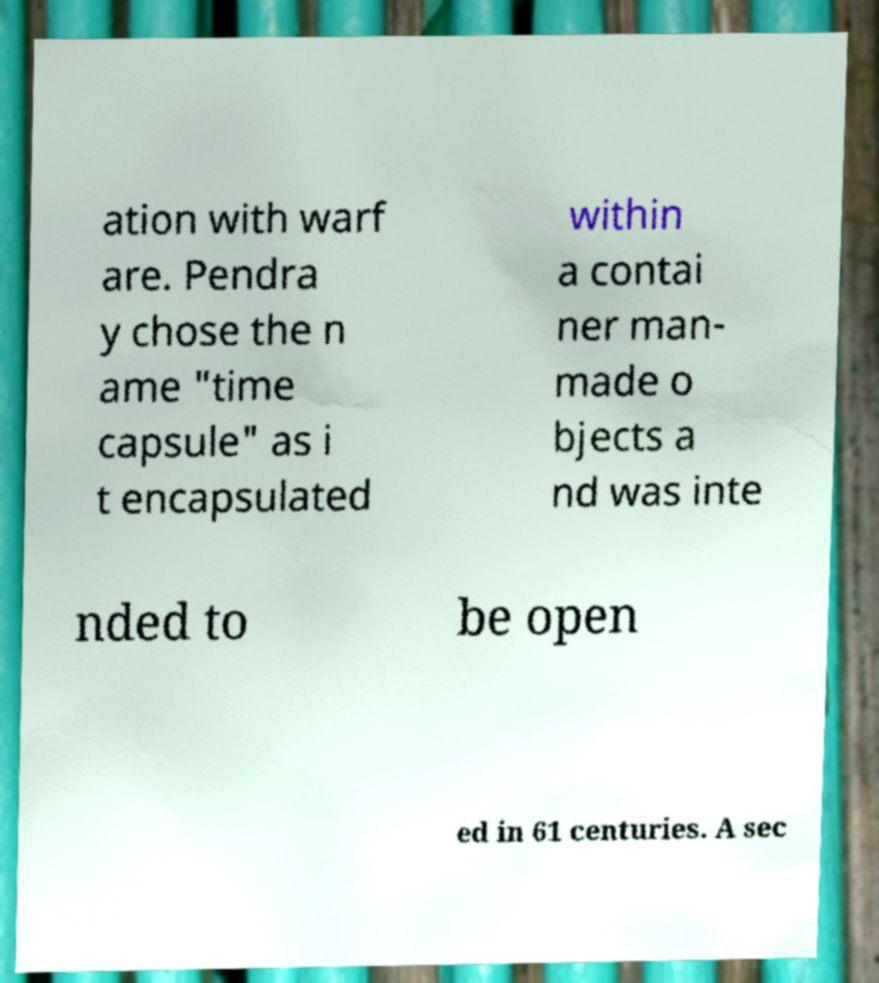Could you assist in decoding the text presented in this image and type it out clearly? ation with warf are. Pendra y chose the n ame "time capsule" as i t encapsulated within a contai ner man- made o bjects a nd was inte nded to be open ed in 61 centuries. A sec 